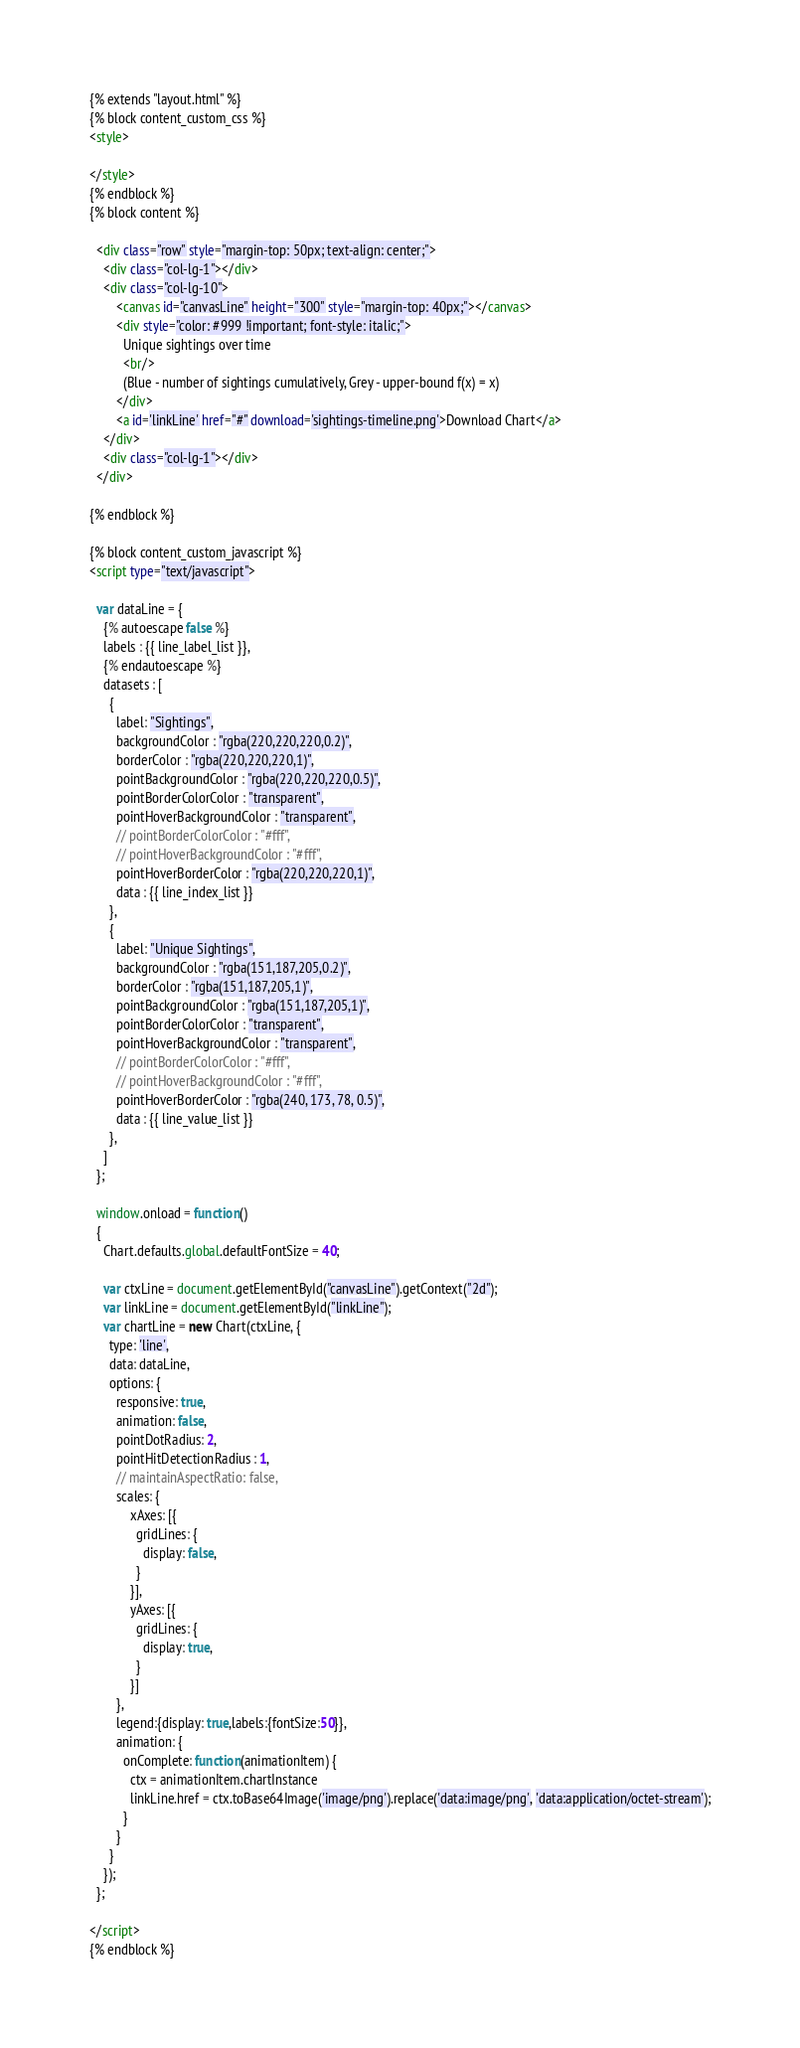<code> <loc_0><loc_0><loc_500><loc_500><_HTML_>{% extends "layout.html" %}
{% block content_custom_css %}
<style>

</style>
{% endblock %}
{% block content %}

  <div class="row" style="margin-top: 50px; text-align: center;">
    <div class="col-lg-1"></div>
    <div class="col-lg-10">
        <canvas id="canvasLine" height="300" style="margin-top: 40px;"></canvas>
        <div style="color: #999 !important; font-style: italic;">
          Unique sightings over time
          <br/>
          (Blue - number of sightings cumulatively, Grey - upper-bound f(x) = x)
        </div>
        <a id='linkLine' href="#" download='sightings-timeline.png'>Download Chart</a>
    </div>
    <div class="col-lg-1"></div>
  </div>

{% endblock %}

{% block content_custom_javascript %}
<script type="text/javascript">

  var dataLine = {
    {% autoescape false %}
    labels : {{ line_label_list }},
    {% endautoescape %}
    datasets : [
      {
        label: "Sightings",
        backgroundColor : "rgba(220,220,220,0.2)",
        borderColor : "rgba(220,220,220,1)",
        pointBackgroundColor : "rgba(220,220,220,0.5)",
        pointBorderColorColor : "transparent",
        pointHoverBackgroundColor : "transparent",
        // pointBorderColorColor : "#fff",
        // pointHoverBackgroundColor : "#fff",
        pointHoverBorderColor : "rgba(220,220,220,1)",
        data : {{ line_index_list }}
      },
      {
        label: "Unique Sightings",
        backgroundColor : "rgba(151,187,205,0.2)",
        borderColor : "rgba(151,187,205,1)",
        pointBackgroundColor : "rgba(151,187,205,1)",
        pointBorderColorColor : "transparent",
        pointHoverBackgroundColor : "transparent",
        // pointBorderColorColor : "#fff",
        // pointHoverBackgroundColor : "#fff",
        pointHoverBorderColor : "rgba(240, 173, 78, 0.5)",
        data : {{ line_value_list }}
      },
    ]
  };

  window.onload = function()
  {
    Chart.defaults.global.defaultFontSize = 40;

    var ctxLine = document.getElementById("canvasLine").getContext("2d");
    var linkLine = document.getElementById("linkLine");
    var chartLine = new Chart(ctxLine, {
      type: 'line',
      data: dataLine,
      options: {
        responsive: true,
        animation: false,
        pointDotRadius: 2,
        pointHitDetectionRadius : 1,
        // maintainAspectRatio: false,
        scales: {
            xAxes: [{
              gridLines: {
                display: false,
              }
            }],
            yAxes: [{
              gridLines: {
                display: true,
              }
            }]
        },
        legend:{display: true,labels:{fontSize:50}},
        animation: {
          onComplete: function(animationItem) {
            ctx = animationItem.chartInstance
            linkLine.href = ctx.toBase64Image('image/png').replace('data:image/png', 'data:application/octet-stream');
          }
        }
      }
    });
  };

</script>
{% endblock %}
</code> 